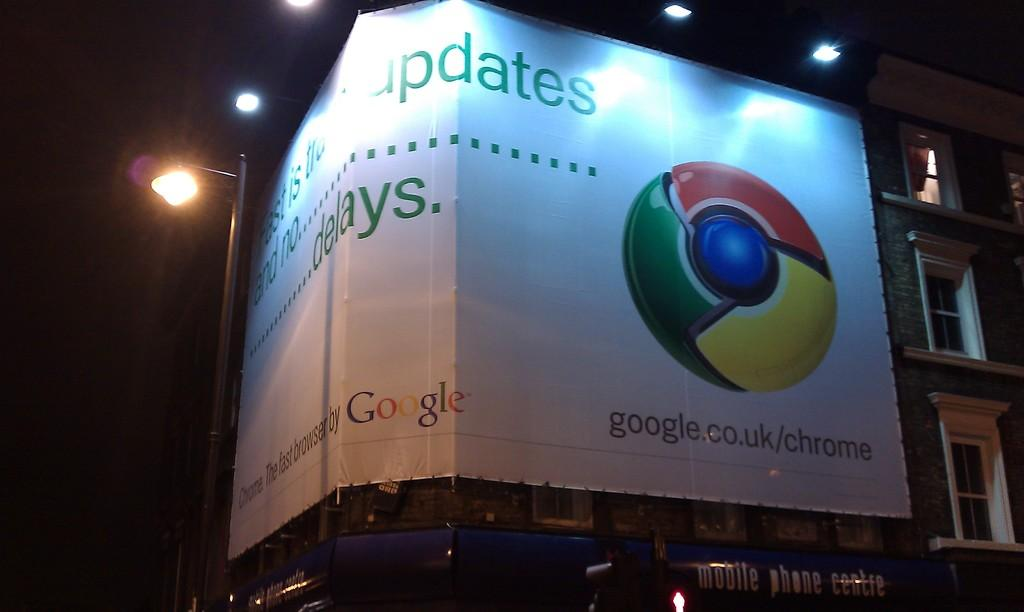<image>
Give a short and clear explanation of the subsequent image. A large Google sign on a building says Updates and delays. 